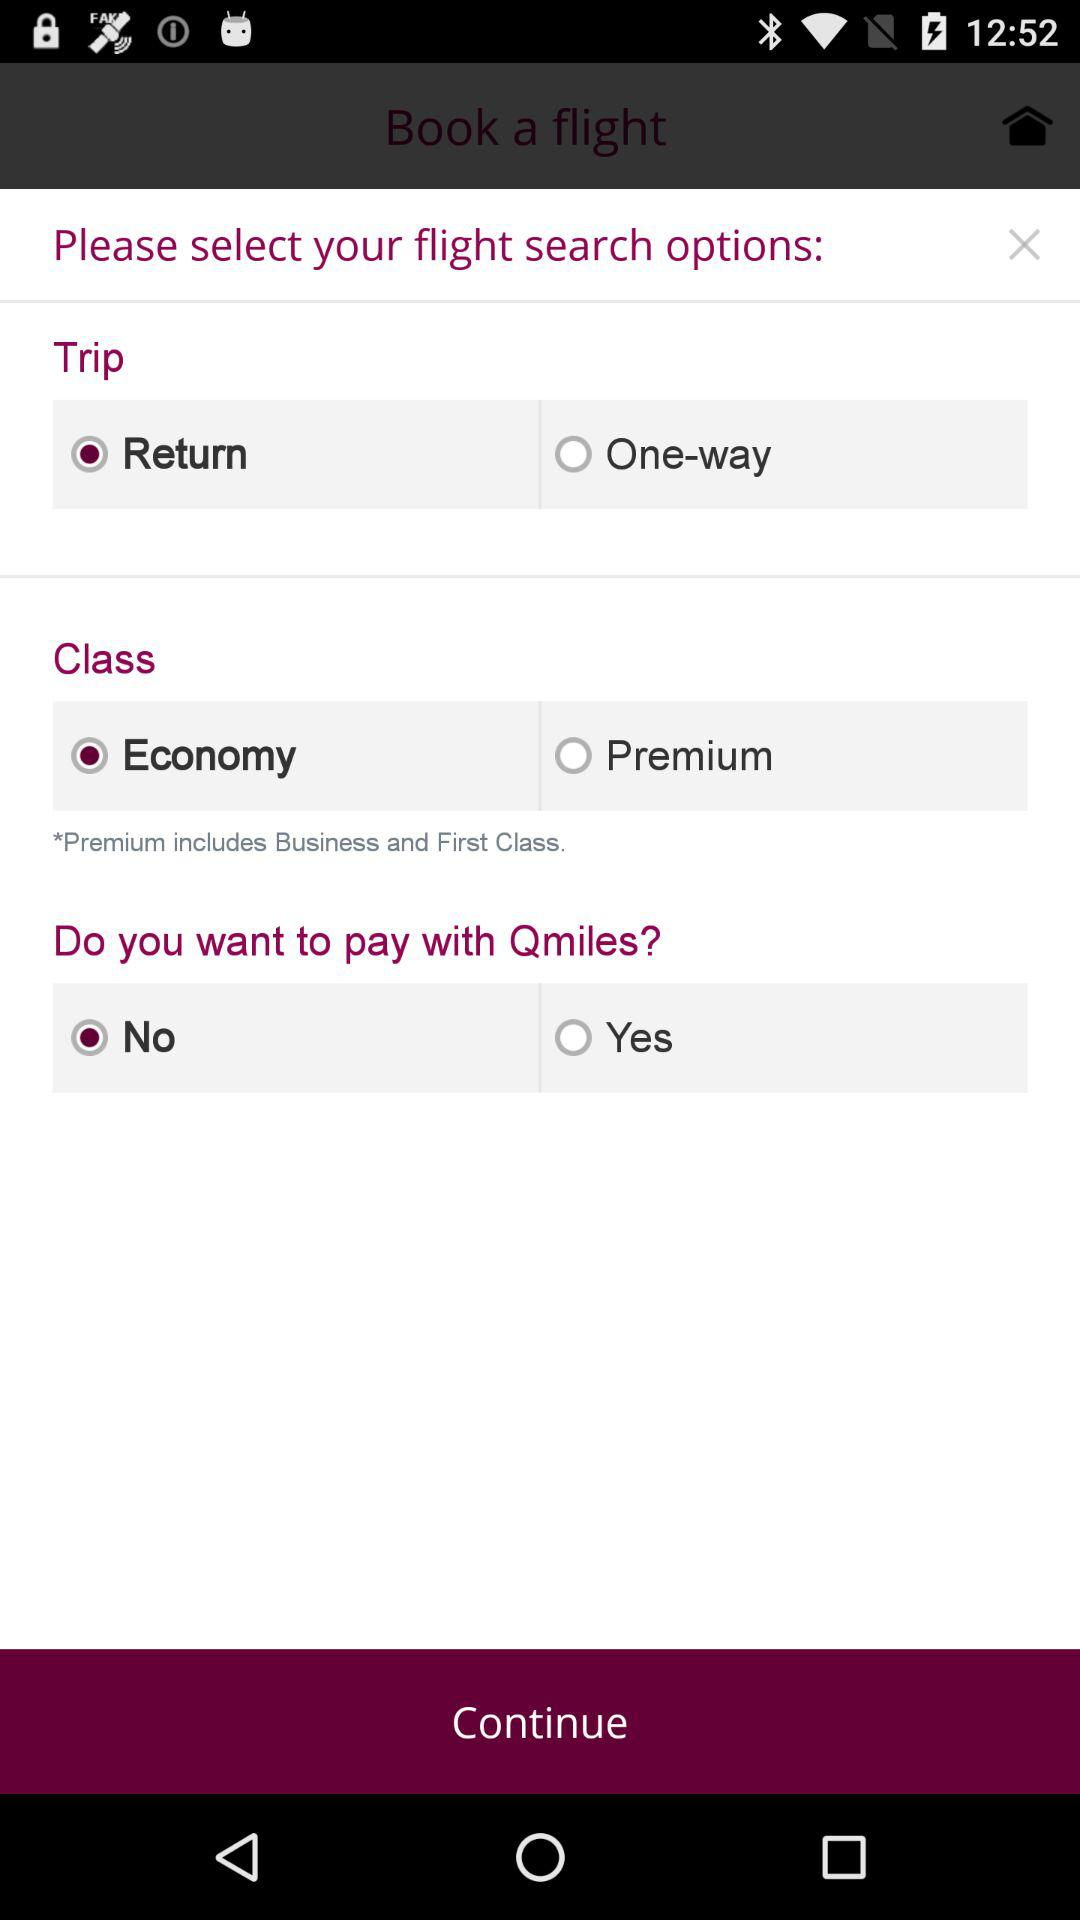What trip option is selected? The return trip option is selected. 